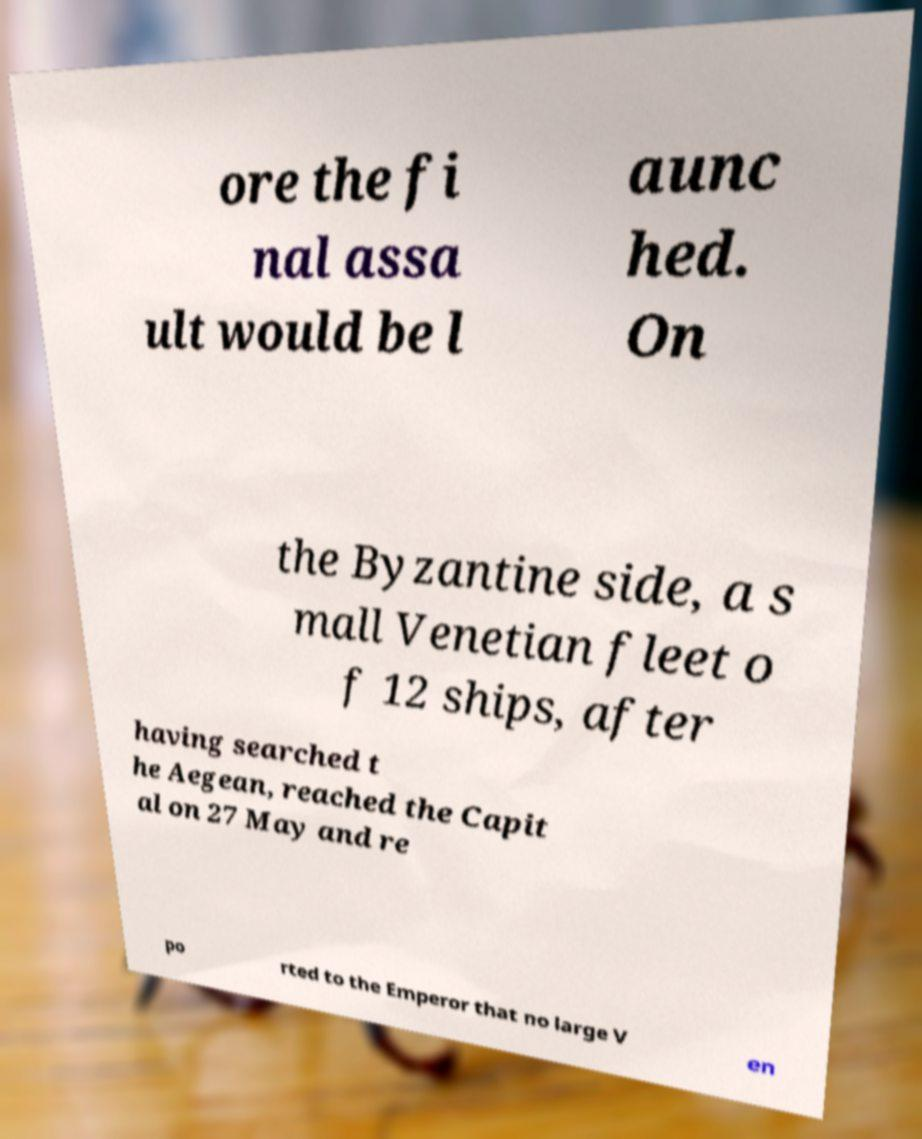Please read and relay the text visible in this image. What does it say? ore the fi nal assa ult would be l aunc hed. On the Byzantine side, a s mall Venetian fleet o f 12 ships, after having searched t he Aegean, reached the Capit al on 27 May and re po rted to the Emperor that no large V en 